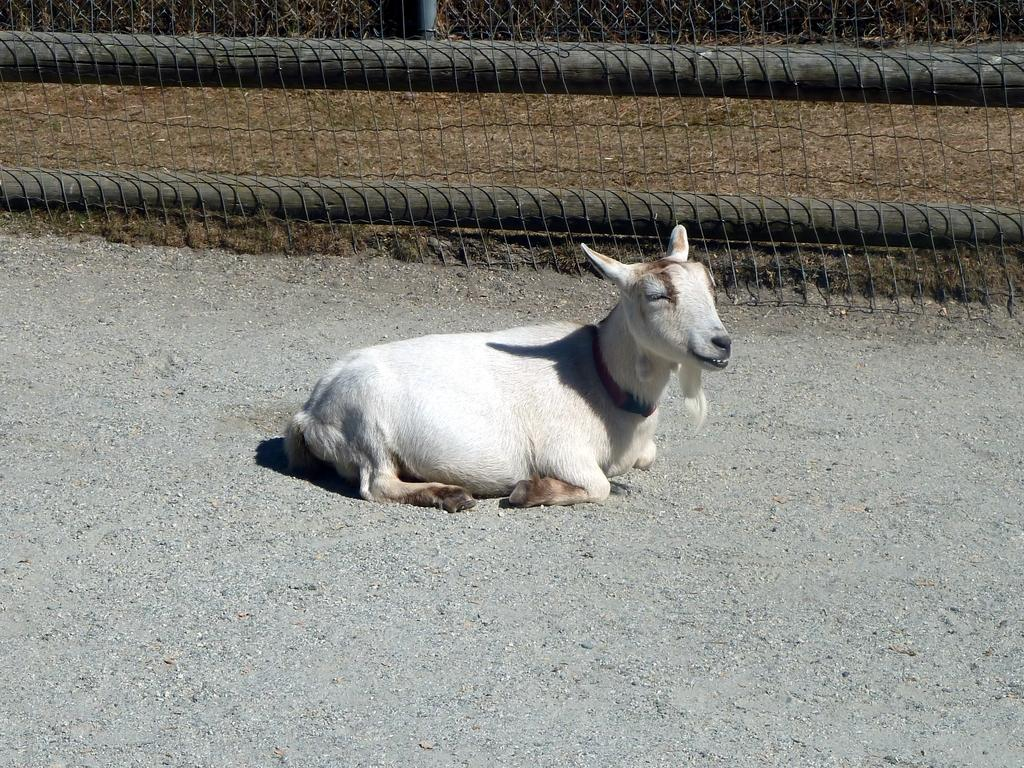What type of animal is on the ground in the image? The specific type of animal cannot be determined from the provided facts. What is the purpose of the fencing in the image? The purpose of the fencing cannot be determined from the provided facts. What are the wooden poles used for in the image? The specific use of the wooden poles cannot be determined from the provided facts. How much coal is stored in the tub in the image? There is no tub or coal present in the image. 